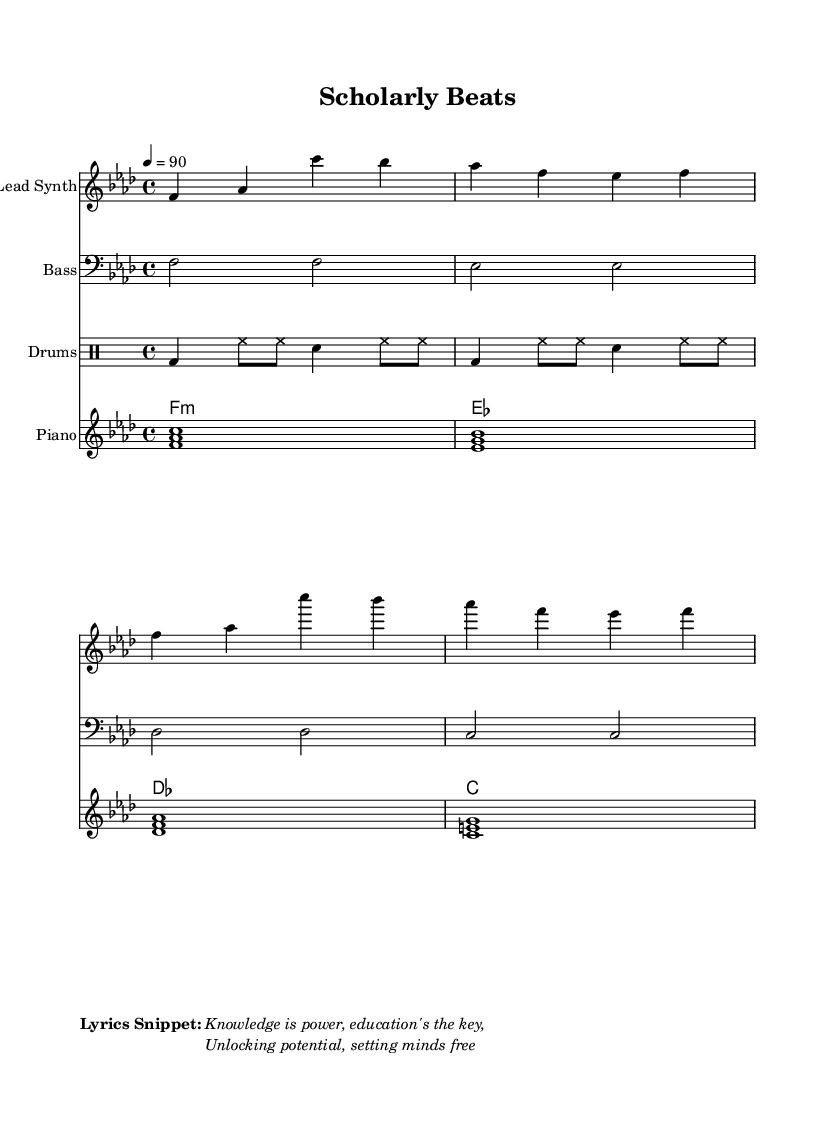What is the key signature of this music? The key signature is indicated at the beginning of the score, showing Bb and Eb. This means the music is written in F minor.
Answer: F minor What is the time signature of this music? The time signature is found next to the key signature, showing a 4 over 4. This indicates that there are four beats per measure.
Answer: 4/4 What is the tempo marking for this piece? The tempo is indicated using a numeric value, showing 4 equals 90. This means there are 90 quarter note beats per minute.
Answer: 90 How many measures are there in the lead synth part? The lead synth part consists of four measures visible in the score. Each measure is separated by vertical lines.
Answer: 4 What is the predominant instrument in the score? The predominant instrument is identified in the header of each staff; in this case, the lead synth staff is labeled as "Lead Synth."
Answer: Lead Synth What lyrics are included in the score? The lyrics are found in the markup section at the end of the score, presented in quotation marks. The lyrics are clearly stated as "Knowledge is power, education's the key, Unlocking potential, setting minds free."
Answer: "Knowledge is power, education's the key, Unlocking potential, setting minds free." What style of music does this represent? The style of music can be inferred from the overall vibe and elements used in the score, including the rhythms, beats, and lyrical content; this is typical of hip hop.
Answer: Hip hop 